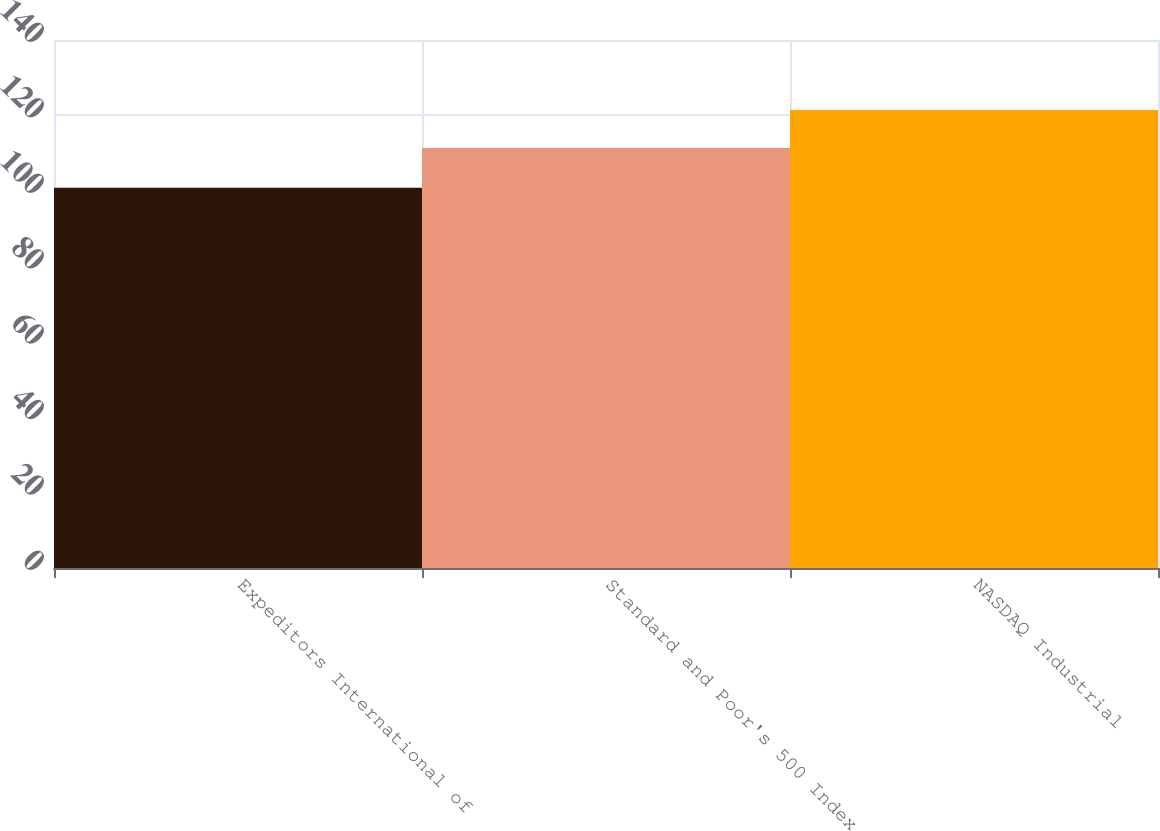Convert chart to OTSL. <chart><loc_0><loc_0><loc_500><loc_500><bar_chart><fcel>Expeditors International of<fcel>Standard and Poor's 500 Index<fcel>NASDAQ Industrial<nl><fcel>100.81<fcel>111.39<fcel>121.41<nl></chart> 